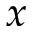Convert formula to latex. <formula><loc_0><loc_0><loc_500><loc_500>x</formula> 